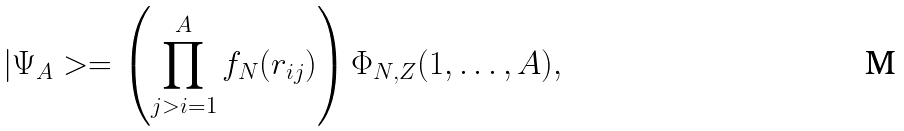<formula> <loc_0><loc_0><loc_500><loc_500>| \Psi _ { A } > = \left ( \prod _ { j > i = 1 } ^ { A } f _ { N } ( r _ { i j } ) \right ) \Phi _ { N , Z } ( 1 , \dots , A ) ,</formula> 